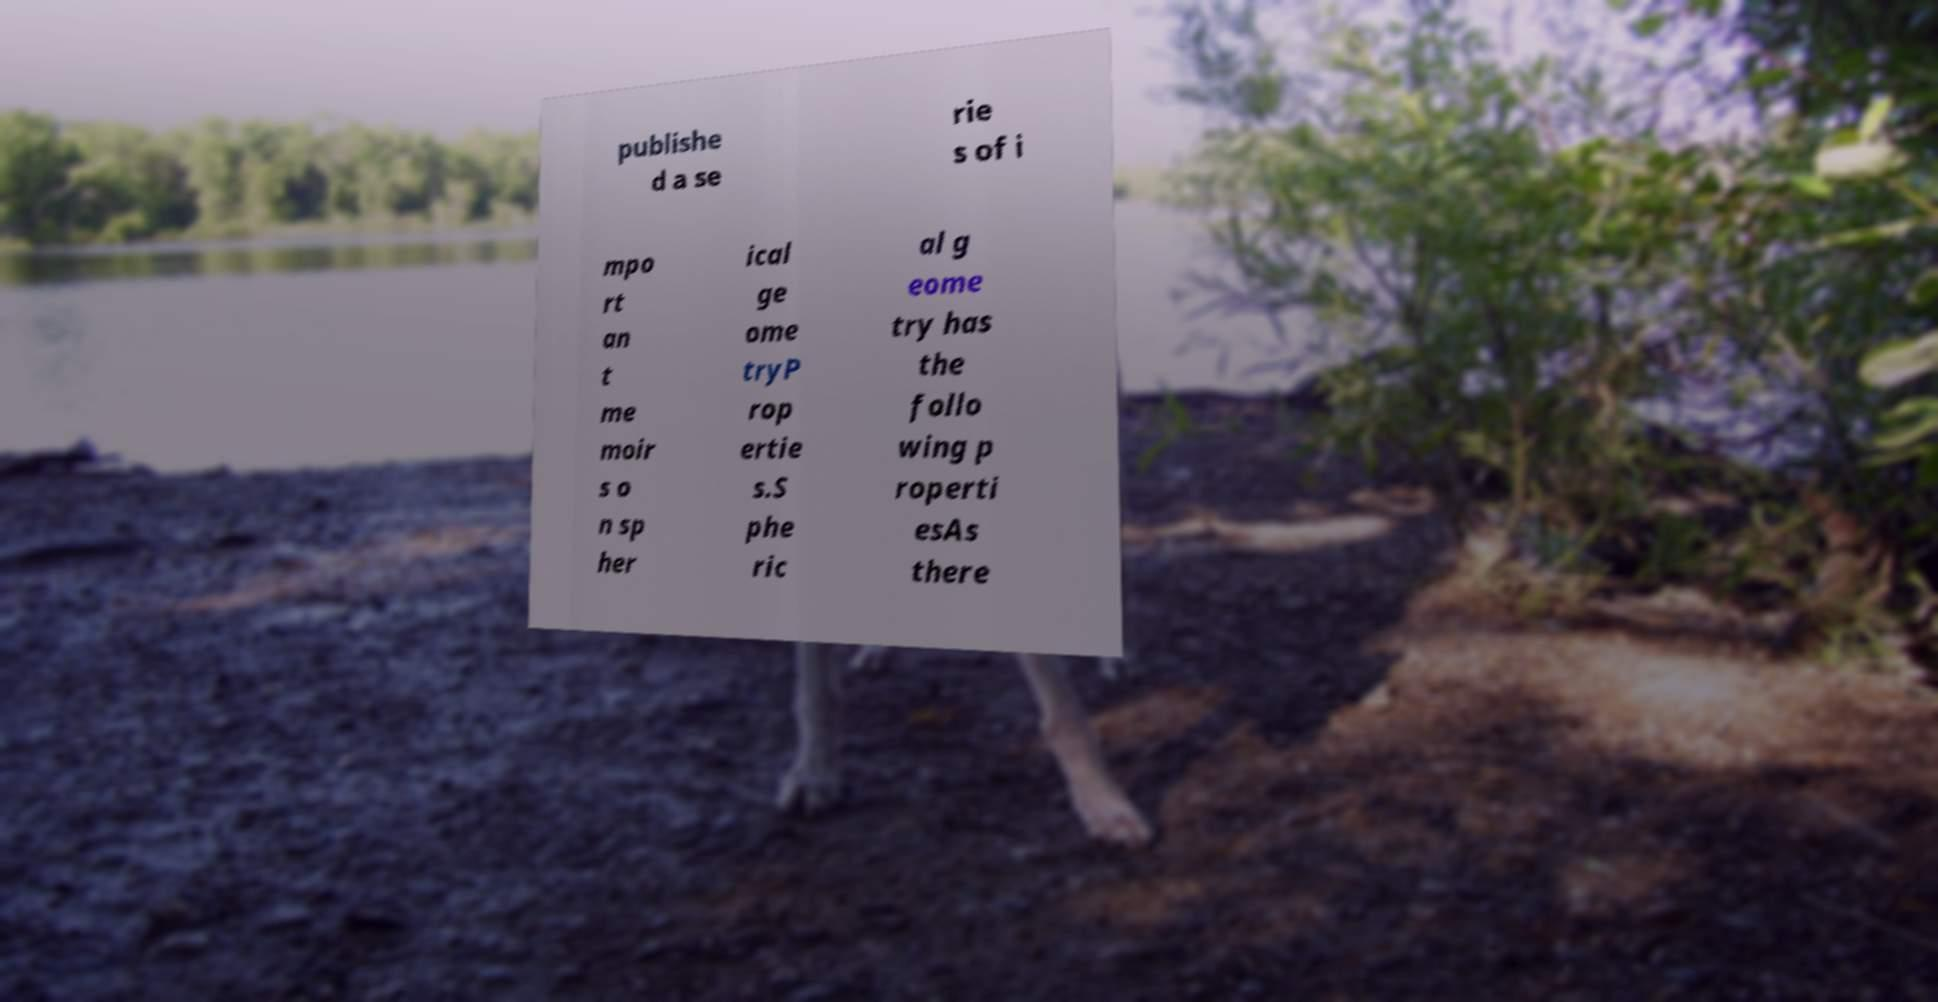Please identify and transcribe the text found in this image. publishe d a se rie s of i mpo rt an t me moir s o n sp her ical ge ome tryP rop ertie s.S phe ric al g eome try has the follo wing p roperti esAs there 